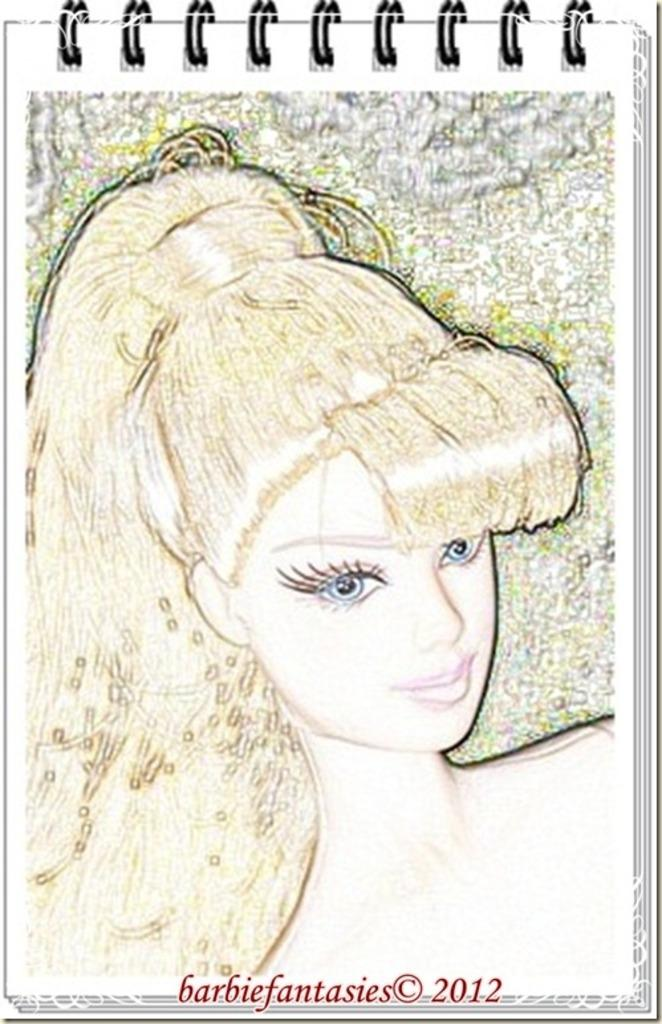What is depicted in the image? The image contains a sketch. What is the subject of the sketch? The sketch is of a doll. Where is the sketch located? The doll is on a piece of paper. What type of paper is the sketch on? The paper is part of a notepad. Is there any additional information visible on the image? Yes, there is a watermark at the bottom of the image. Are there any ants crawling on the veil of the doll in the sketch? There is no veil present on the doll in the sketch, and no ants are visible in the image. 